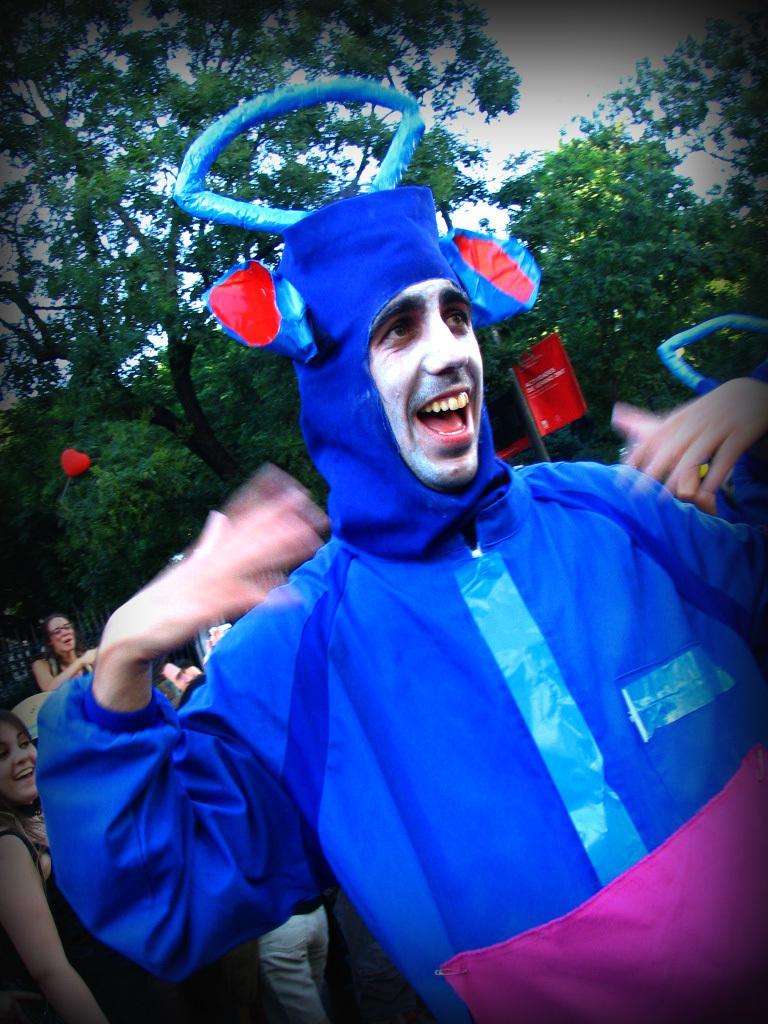How would you summarize this image in a sentence or two? In this image we can see few people. There is an advertising board in the image. There are many trees and plants in the image. 